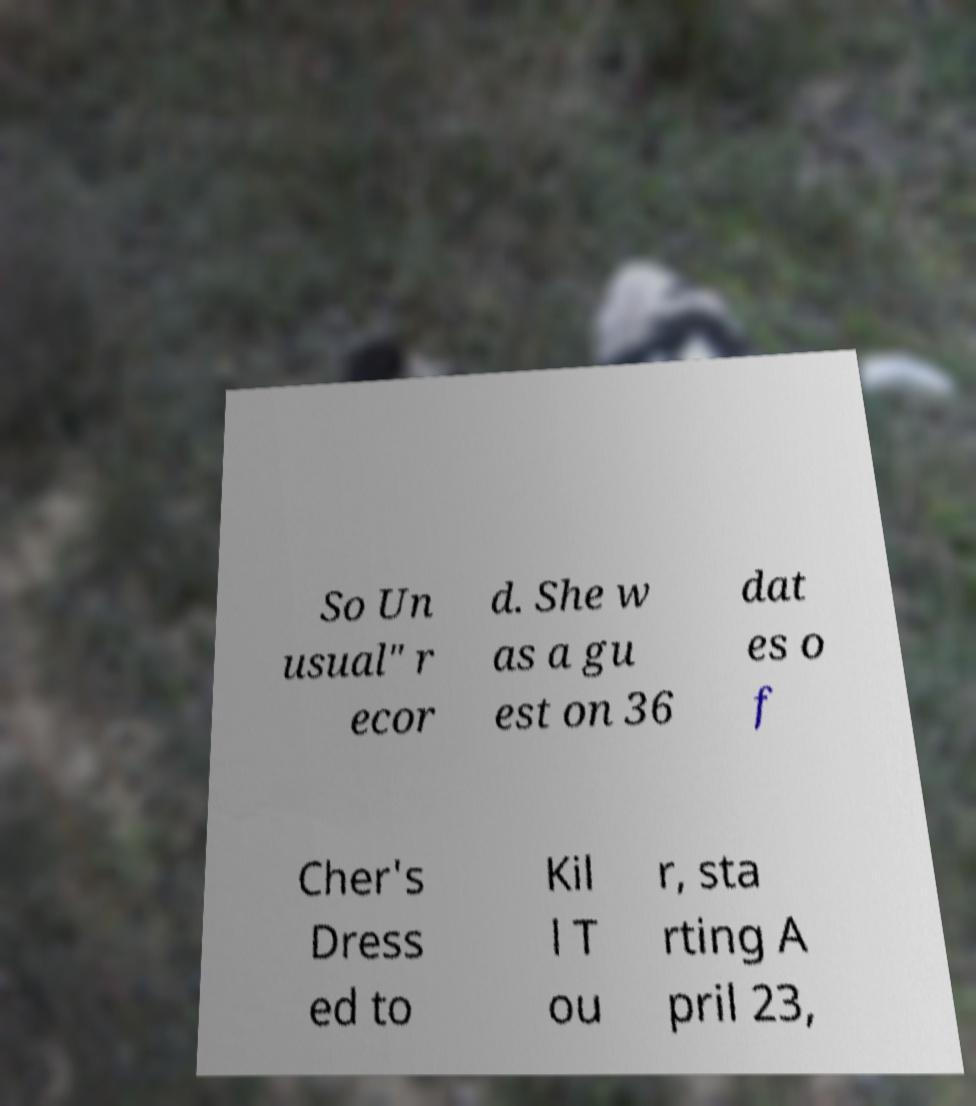Can you read and provide the text displayed in the image?This photo seems to have some interesting text. Can you extract and type it out for me? So Un usual" r ecor d. She w as a gu est on 36 dat es o f Cher's Dress ed to Kil l T ou r, sta rting A pril 23, 